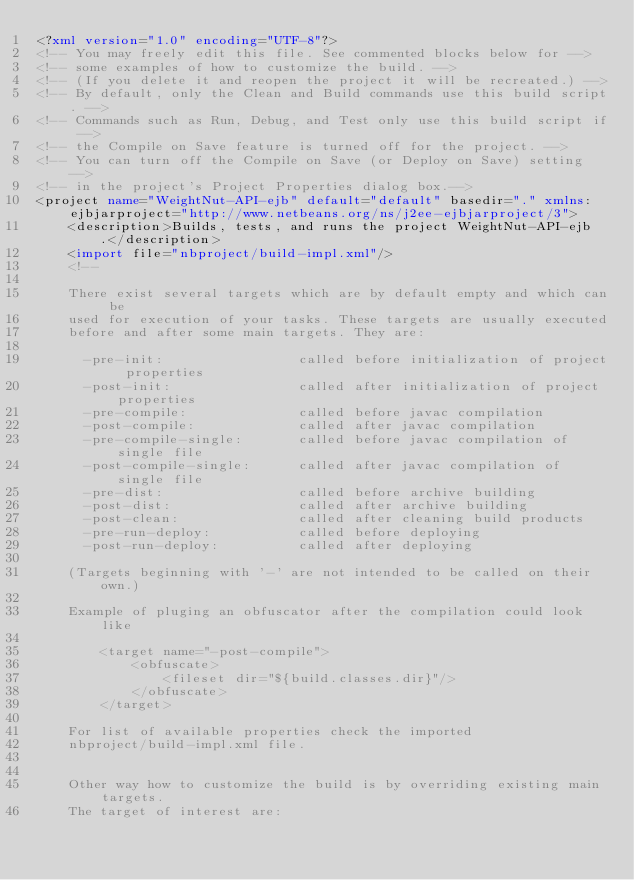Convert code to text. <code><loc_0><loc_0><loc_500><loc_500><_XML_><?xml version="1.0" encoding="UTF-8"?>
<!-- You may freely edit this file. See commented blocks below for -->
<!-- some examples of how to customize the build. -->
<!-- (If you delete it and reopen the project it will be recreated.) -->
<!-- By default, only the Clean and Build commands use this build script. -->
<!-- Commands such as Run, Debug, and Test only use this build script if -->
<!-- the Compile on Save feature is turned off for the project. -->
<!-- You can turn off the Compile on Save (or Deploy on Save) setting -->
<!-- in the project's Project Properties dialog box.-->
<project name="WeightNut-API-ejb" default="default" basedir="." xmlns:ejbjarproject="http://www.netbeans.org/ns/j2ee-ejbjarproject/3">
    <description>Builds, tests, and runs the project WeightNut-API-ejb.</description>
    <import file="nbproject/build-impl.xml"/>
    <!--

    There exist several targets which are by default empty and which can be 
    used for execution of your tasks. These targets are usually executed 
    before and after some main targets. They are: 

      -pre-init:                 called before initialization of project properties
      -post-init:                called after initialization of project properties
      -pre-compile:              called before javac compilation
      -post-compile:             called after javac compilation
      -pre-compile-single:       called before javac compilation of single file
      -post-compile-single:      called after javac compilation of single file
      -pre-dist:                 called before archive building
      -post-dist:                called after archive building
      -post-clean:               called after cleaning build products
      -pre-run-deploy:           called before deploying
      -post-run-deploy:          called after deploying

    (Targets beginning with '-' are not intended to be called on their own.)

    Example of pluging an obfuscator after the compilation could look like 

        <target name="-post-compile">
            <obfuscate>
                <fileset dir="${build.classes.dir}"/>
            </obfuscate>
        </target>

    For list of available properties check the imported 
    nbproject/build-impl.xml file. 


    Other way how to customize the build is by overriding existing main targets.
    The target of interest are: 
</code> 